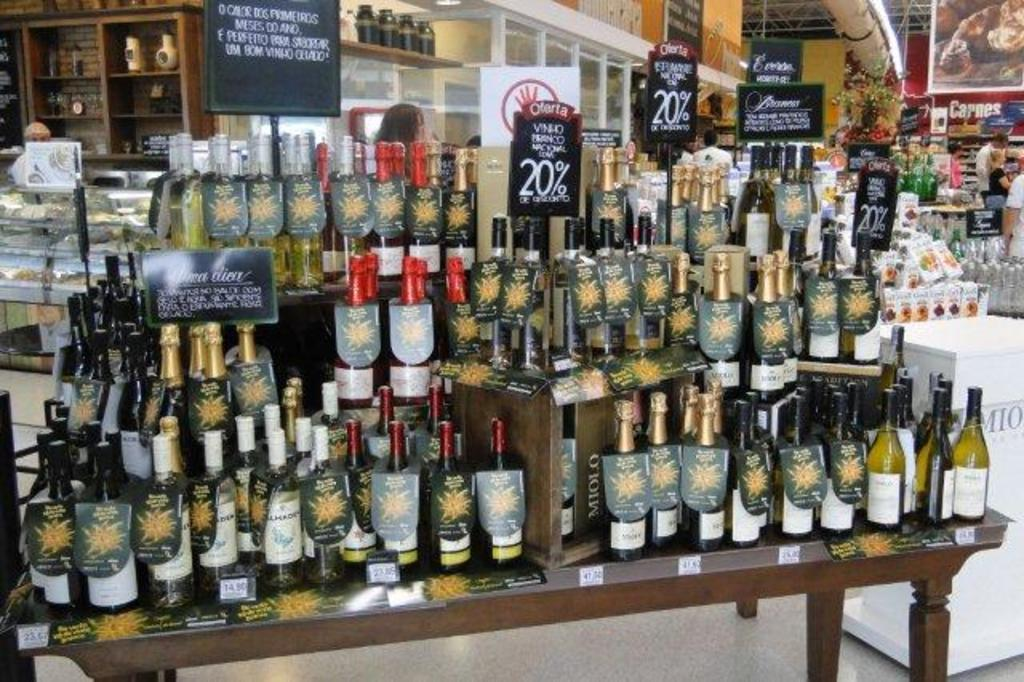What is the main subject of the image? The main subject of the image is many wine bottles. Where are the wine bottles located? The wine bottles are on a table. How many geese are sitting on the branch in the image? There are no geese or branches present in the image; it only features wine bottles on a table. 